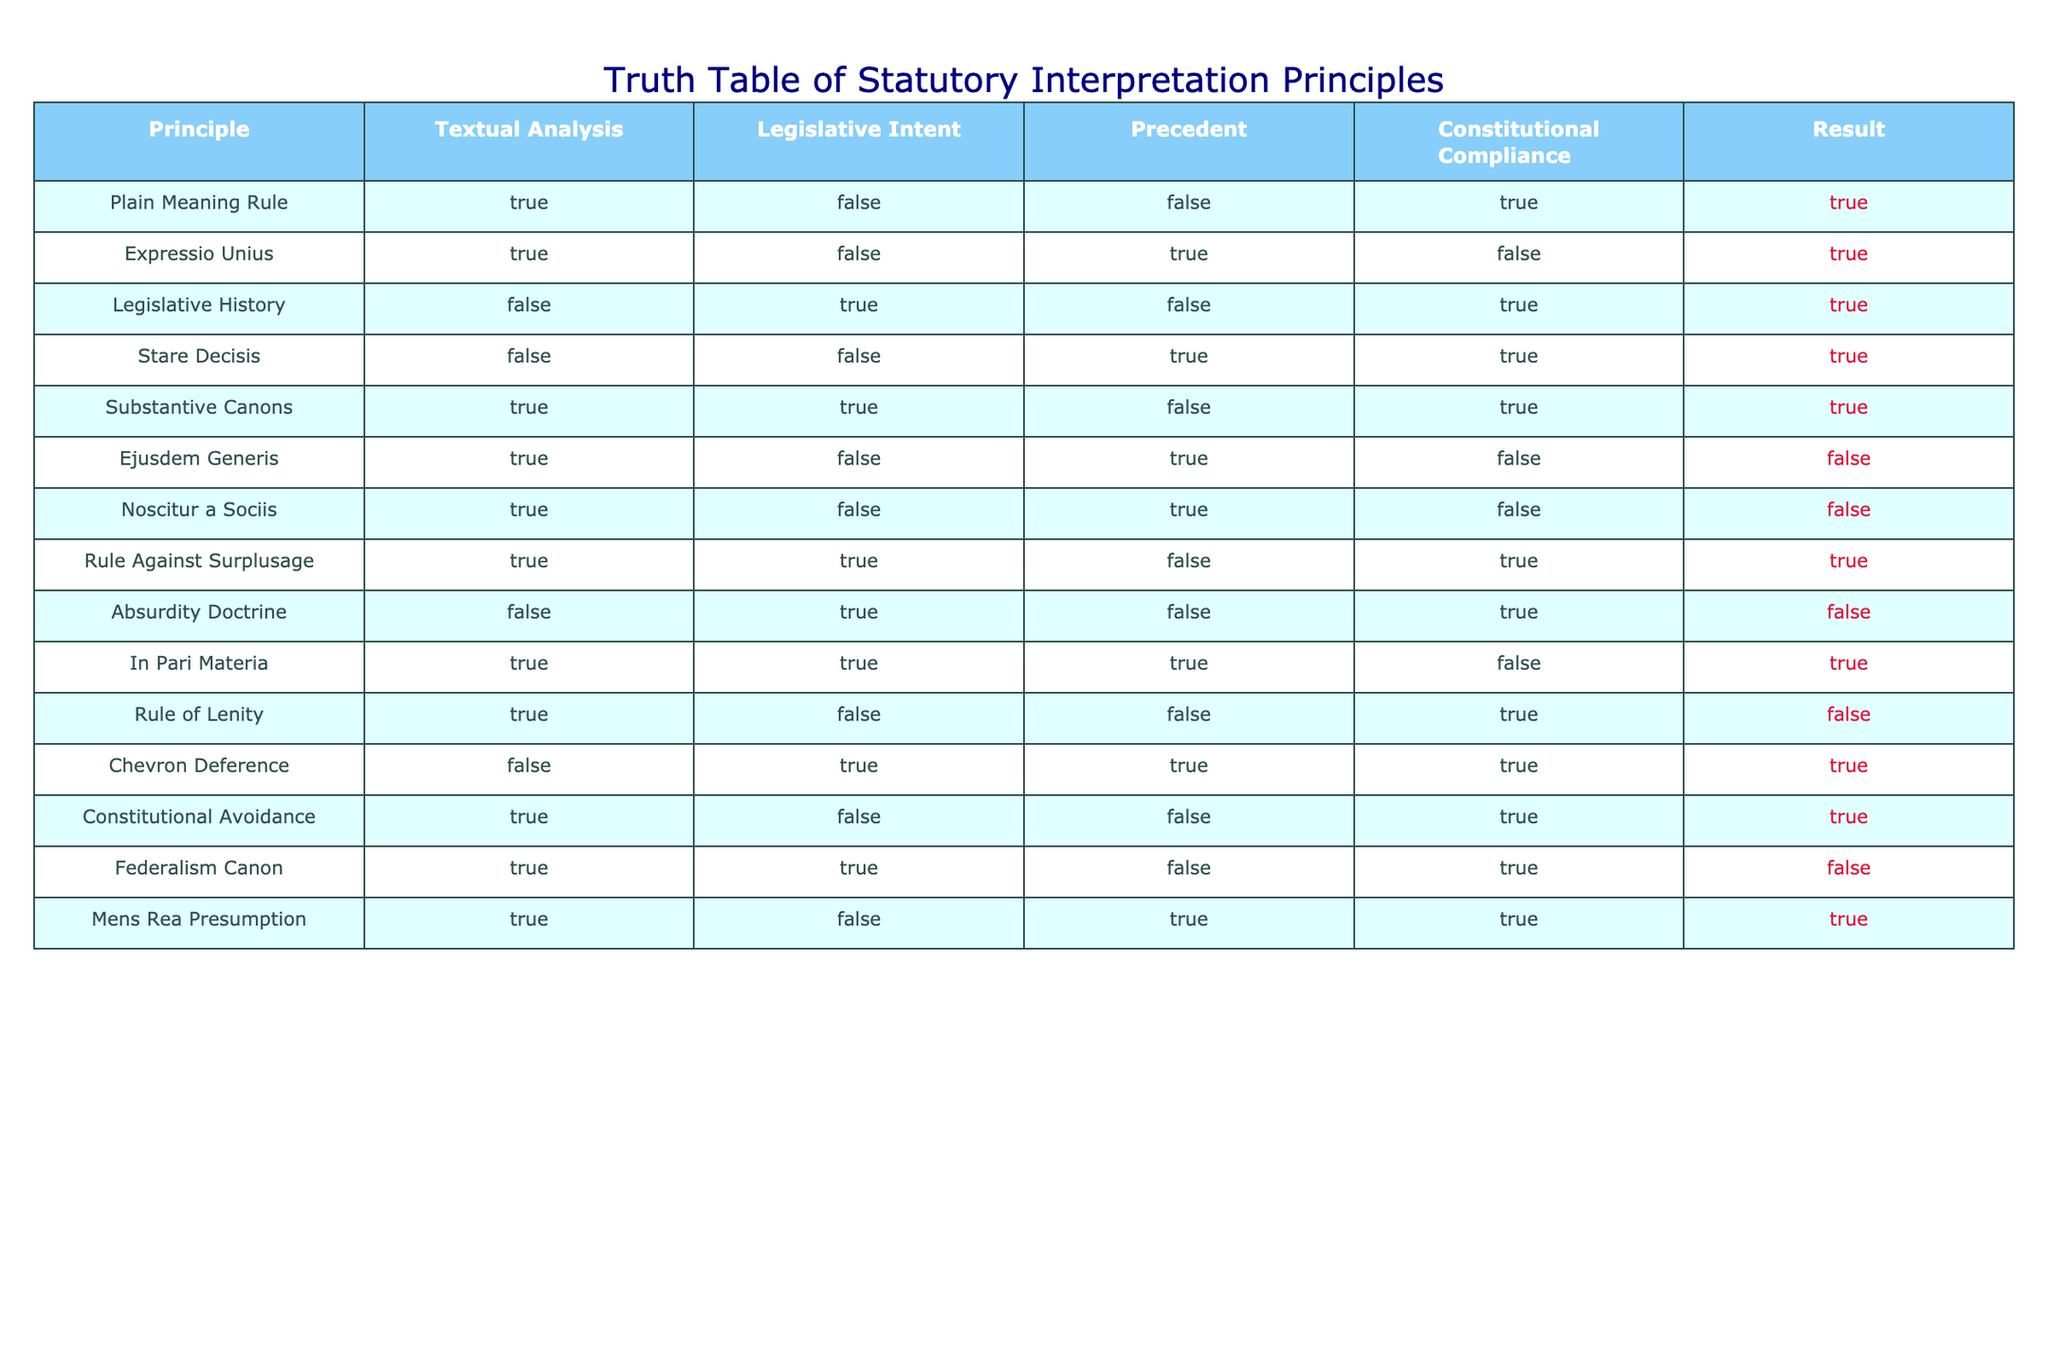What is the result of applying the Plain Meaning Rule? The row for the Plain Meaning Rule shows a result of TRUE, meaning this principle leads to a favorable interpretation in terms of statutory interpretation.
Answer: TRUE Which principles show a TRUE result when using textual analysis? The principles that show a TRUE result under the textual analysis column are: Plain Meaning Rule, Expressio Unius, Substantive Canons, Ejusdem Generis, Noscitur a Sociis, Rule Against Surplusage, In Pari Materia, Constitutional Avoidance, Federalism Canon, and Mens Rea Presumption. There are a total of 10 principles.
Answer: 10 Does the Expressio Unius principle comply with constitutional requirements? Looking at the Expressio Unius row, the compliance with constitutional requirements is marked as FALSE, indicating that this principle does not assure constitutional compliance.
Answer: FALSE How many principles utilize Legislative Intent while yielding a TRUE result? By examining the Legislative Intent column, the principles that yield a TRUE result are Legislative History, Substantive Canons, Chevron Deference, and Federalism Canon. This gives us a total of 4 principles that satisfy both conditions.
Answer: 4 Is it true that any principles yield a FALSE result for both Legislative Intent and Precedent? By analyzing the rows, the Stare Decisis and Ejusdem Generis principles confirm a FALSE result for Legislative Intent and Precedent. This indicates there are indeed principles that do not rely on either aspect.
Answer: TRUE What is the total number of principles with a TRUE result in the 'Result' column? Reviewing the Result column, a total of 8 principles show a result of TRUE, which indicates successful interpretation outcomes based on the principles listed.
Answer: 8 How many principles apply the Rule of Lenity and yield a TRUE result? The Rule of Lenity appears in the table but shows a result of FALSE, meaning this principle does not yield a favorable interpretation outcome under statutory interpretation principles.
Answer: 0 Which principle has a TRUE result for Precedent but a FALSE result for Legislative Intent? The principle that has a TRUE result for Precedent and a FALSE outcome for Legislative Intent is Stare Decisis. This indicates it relies on past decisions without considering legislative purpose.
Answer: Stare Decisis How many principles are both compliant with constitutional requirements and yield a TRUE result? From the table, the principles showing compliance with constitutional requirements while resulting in TRUE are Plain Meaning Rule, Legislative History, Stare Decisis, Substantive Canons, Rule Against Surplusage, In Pari Materia, Chevron Deference, and Constitutional Avoidance, totaling 8 principles.
Answer: 8 